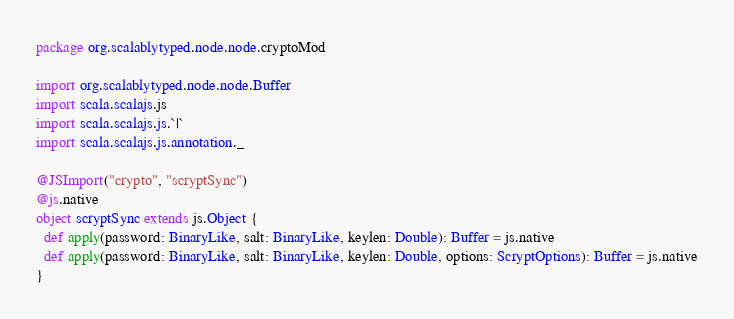<code> <loc_0><loc_0><loc_500><loc_500><_Scala_>package org.scalablytyped.node.node.cryptoMod

import org.scalablytyped.node.node.Buffer
import scala.scalajs.js
import scala.scalajs.js.`|`
import scala.scalajs.js.annotation._

@JSImport("crypto", "scryptSync")
@js.native
object scryptSync extends js.Object {
  def apply(password: BinaryLike, salt: BinaryLike, keylen: Double): Buffer = js.native
  def apply(password: BinaryLike, salt: BinaryLike, keylen: Double, options: ScryptOptions): Buffer = js.native
}

</code> 